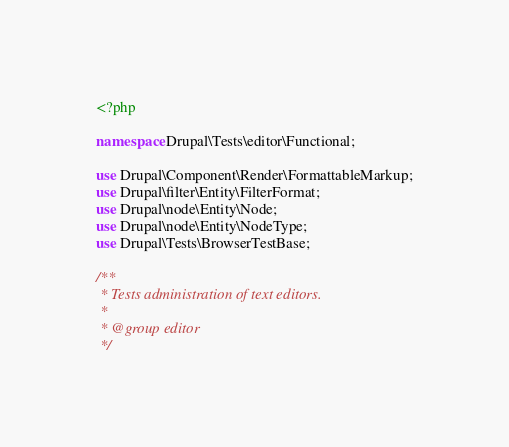<code> <loc_0><loc_0><loc_500><loc_500><_PHP_><?php

namespace Drupal\Tests\editor\Functional;

use Drupal\Component\Render\FormattableMarkup;
use Drupal\filter\Entity\FilterFormat;
use Drupal\node\Entity\Node;
use Drupal\node\Entity\NodeType;
use Drupal\Tests\BrowserTestBase;

/**
 * Tests administration of text editors.
 *
 * @group editor
 */</code> 